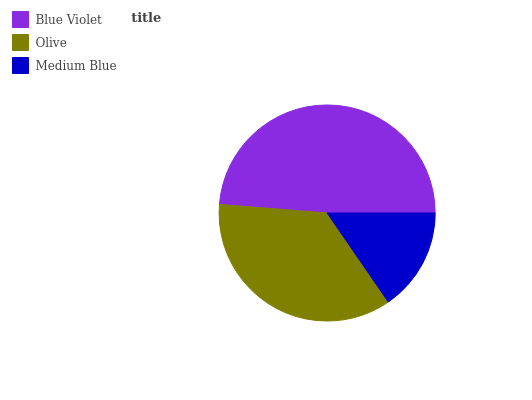Is Medium Blue the minimum?
Answer yes or no. Yes. Is Blue Violet the maximum?
Answer yes or no. Yes. Is Olive the minimum?
Answer yes or no. No. Is Olive the maximum?
Answer yes or no. No. Is Blue Violet greater than Olive?
Answer yes or no. Yes. Is Olive less than Blue Violet?
Answer yes or no. Yes. Is Olive greater than Blue Violet?
Answer yes or no. No. Is Blue Violet less than Olive?
Answer yes or no. No. Is Olive the high median?
Answer yes or no. Yes. Is Olive the low median?
Answer yes or no. Yes. Is Blue Violet the high median?
Answer yes or no. No. Is Blue Violet the low median?
Answer yes or no. No. 